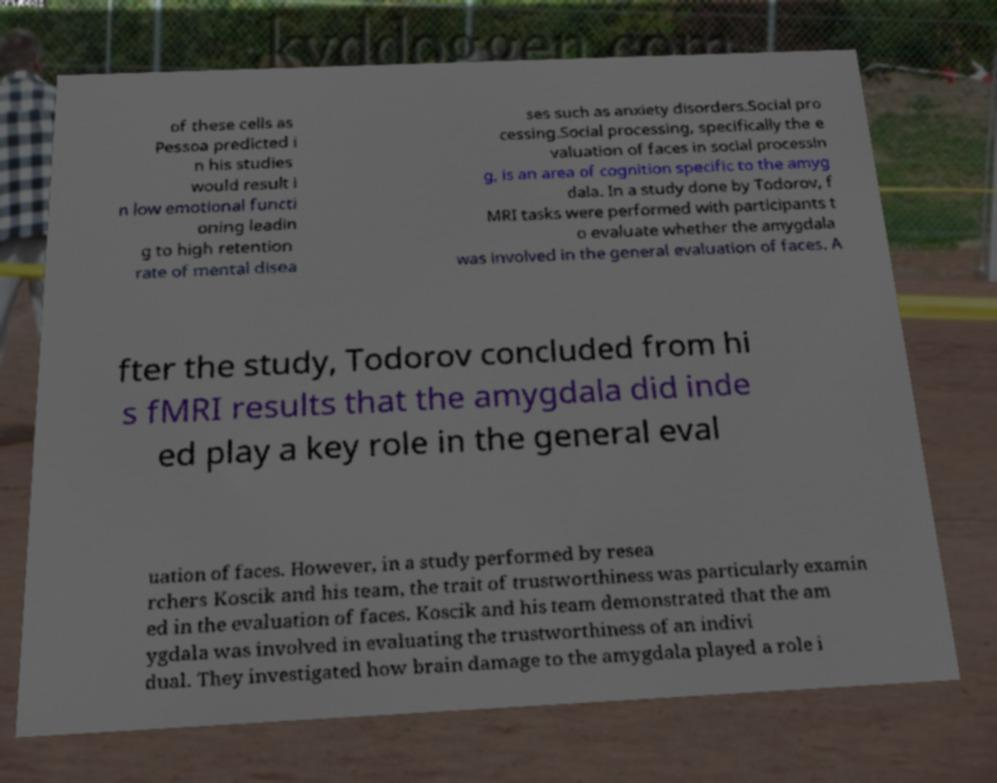Can you accurately transcribe the text from the provided image for me? of these cells as Pessoa predicted i n his studies would result i n low emotional functi oning leadin g to high retention rate of mental disea ses such as anxiety disorders.Social pro cessing.Social processing, specifically the e valuation of faces in social processin g, is an area of cognition specific to the amyg dala. In a study done by Todorov, f MRI tasks were performed with participants t o evaluate whether the amygdala was involved in the general evaluation of faces. A fter the study, Todorov concluded from hi s fMRI results that the amygdala did inde ed play a key role in the general eval uation of faces. However, in a study performed by resea rchers Koscik and his team, the trait of trustworthiness was particularly examin ed in the evaluation of faces. Koscik and his team demonstrated that the am ygdala was involved in evaluating the trustworthiness of an indivi dual. They investigated how brain damage to the amygdala played a role i 